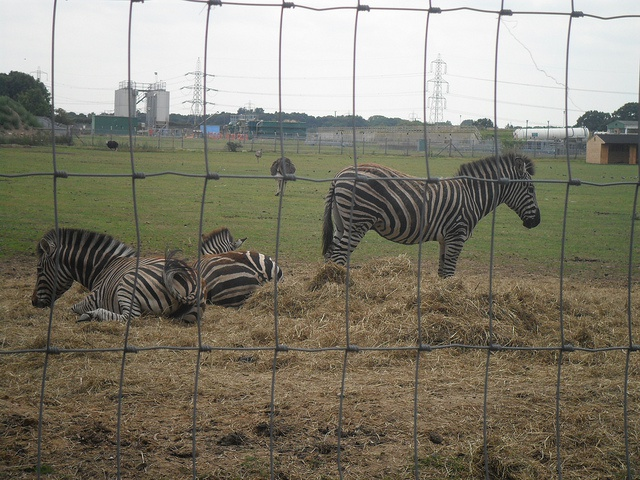Describe the objects in this image and their specific colors. I can see zebra in white, gray, and black tones, zebra in white, black, and gray tones, zebra in white, black, and gray tones, and bird in white, gray, and black tones in this image. 